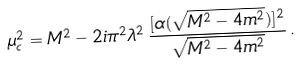Convert formula to latex. <formula><loc_0><loc_0><loc_500><loc_500>\mu ^ { 2 } _ { c } = M ^ { 2 } - 2 i \pi ^ { 2 } \lambda ^ { 2 } \, \frac { [ \alpha ( \sqrt { M ^ { 2 } - 4 m ^ { 2 } } ) ] ^ { 2 } } { \sqrt { M ^ { 2 } - 4 m ^ { 2 } } } \, .</formula> 